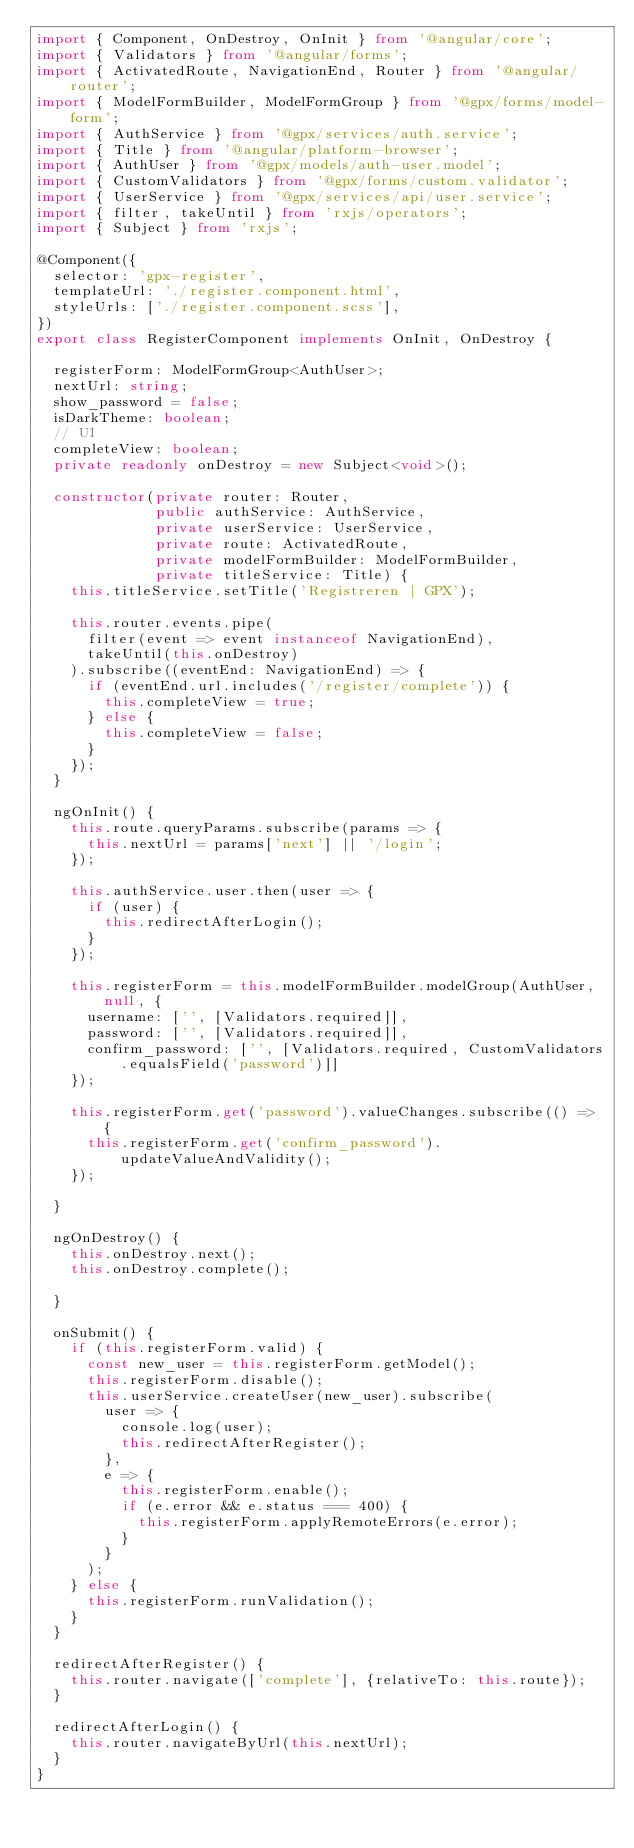<code> <loc_0><loc_0><loc_500><loc_500><_TypeScript_>import { Component, OnDestroy, OnInit } from '@angular/core';
import { Validators } from '@angular/forms';
import { ActivatedRoute, NavigationEnd, Router } from '@angular/router';
import { ModelFormBuilder, ModelFormGroup } from '@gpx/forms/model-form';
import { AuthService } from '@gpx/services/auth.service';
import { Title } from '@angular/platform-browser';
import { AuthUser } from '@gpx/models/auth-user.model';
import { CustomValidators } from '@gpx/forms/custom.validator';
import { UserService } from '@gpx/services/api/user.service';
import { filter, takeUntil } from 'rxjs/operators';
import { Subject } from 'rxjs';

@Component({
  selector: 'gpx-register',
  templateUrl: './register.component.html',
  styleUrls: ['./register.component.scss'],
})
export class RegisterComponent implements OnInit, OnDestroy {

  registerForm: ModelFormGroup<AuthUser>;
  nextUrl: string;
  show_password = false;
  isDarkTheme: boolean;
  // UI
  completeView: boolean;
  private readonly onDestroy = new Subject<void>();

  constructor(private router: Router,
              public authService: AuthService,
              private userService: UserService,
              private route: ActivatedRoute,
              private modelFormBuilder: ModelFormBuilder,
              private titleService: Title) {
    this.titleService.setTitle('Registreren | GPX');

    this.router.events.pipe(
      filter(event => event instanceof NavigationEnd),
      takeUntil(this.onDestroy)
    ).subscribe((eventEnd: NavigationEnd) => {
      if (eventEnd.url.includes('/register/complete')) {
        this.completeView = true;
      } else {
        this.completeView = false;
      }
    });
  }

  ngOnInit() {
    this.route.queryParams.subscribe(params => {
      this.nextUrl = params['next'] || '/login';
    });

    this.authService.user.then(user => {
      if (user) {
        this.redirectAfterLogin();
      }
    });

    this.registerForm = this.modelFormBuilder.modelGroup(AuthUser, null, {
      username: ['', [Validators.required]],
      password: ['', [Validators.required]],
      confirm_password: ['', [Validators.required, CustomValidators.equalsField('password')]]
    });

    this.registerForm.get('password').valueChanges.subscribe(() => {
      this.registerForm.get('confirm_password').updateValueAndValidity();
    });

  }

  ngOnDestroy() {
    this.onDestroy.next();
    this.onDestroy.complete();

  }

  onSubmit() {
    if (this.registerForm.valid) {
      const new_user = this.registerForm.getModel();
      this.registerForm.disable();
      this.userService.createUser(new_user).subscribe(
        user => {
          console.log(user);
          this.redirectAfterRegister();
        },
        e => {
          this.registerForm.enable();
          if (e.error && e.status === 400) {
            this.registerForm.applyRemoteErrors(e.error);
          }
        }
      );
    } else {
      this.registerForm.runValidation();
    }
  }

  redirectAfterRegister() {
    this.router.navigate(['complete'], {relativeTo: this.route});
  }

  redirectAfterLogin() {
    this.router.navigateByUrl(this.nextUrl);
  }
}
</code> 